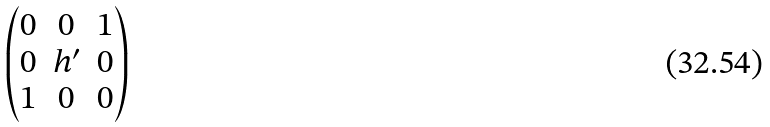<formula> <loc_0><loc_0><loc_500><loc_500>\begin{pmatrix} 0 & 0 & 1 \\ 0 & h ^ { \prime } & 0 \\ 1 & 0 & 0 \end{pmatrix}</formula> 